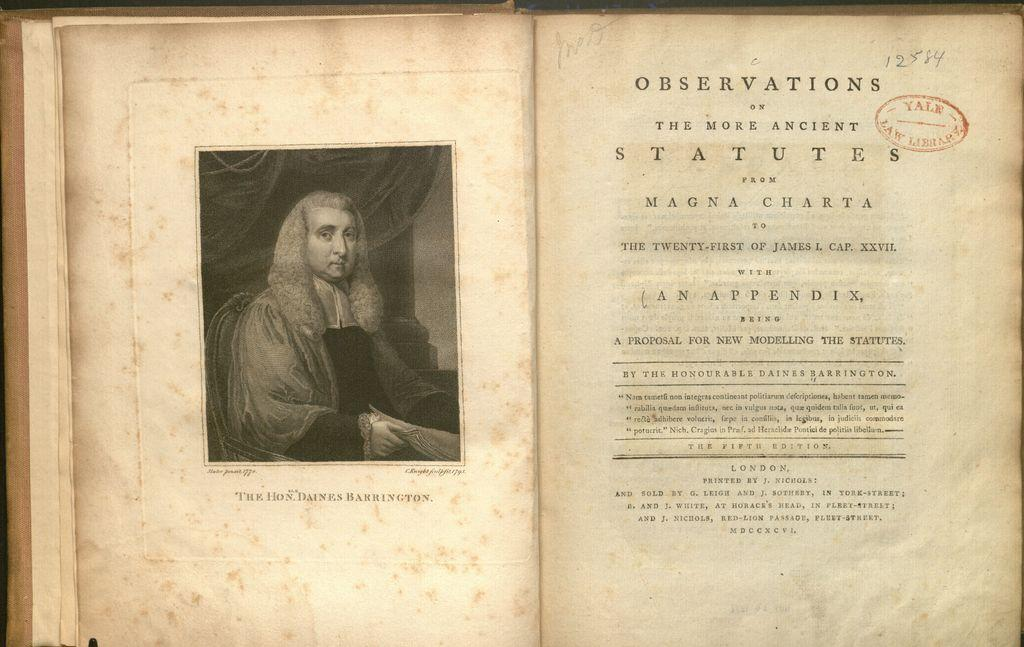<image>
Write a terse but informative summary of the picture. The open book is about taking a closer look at the Magna Charta 